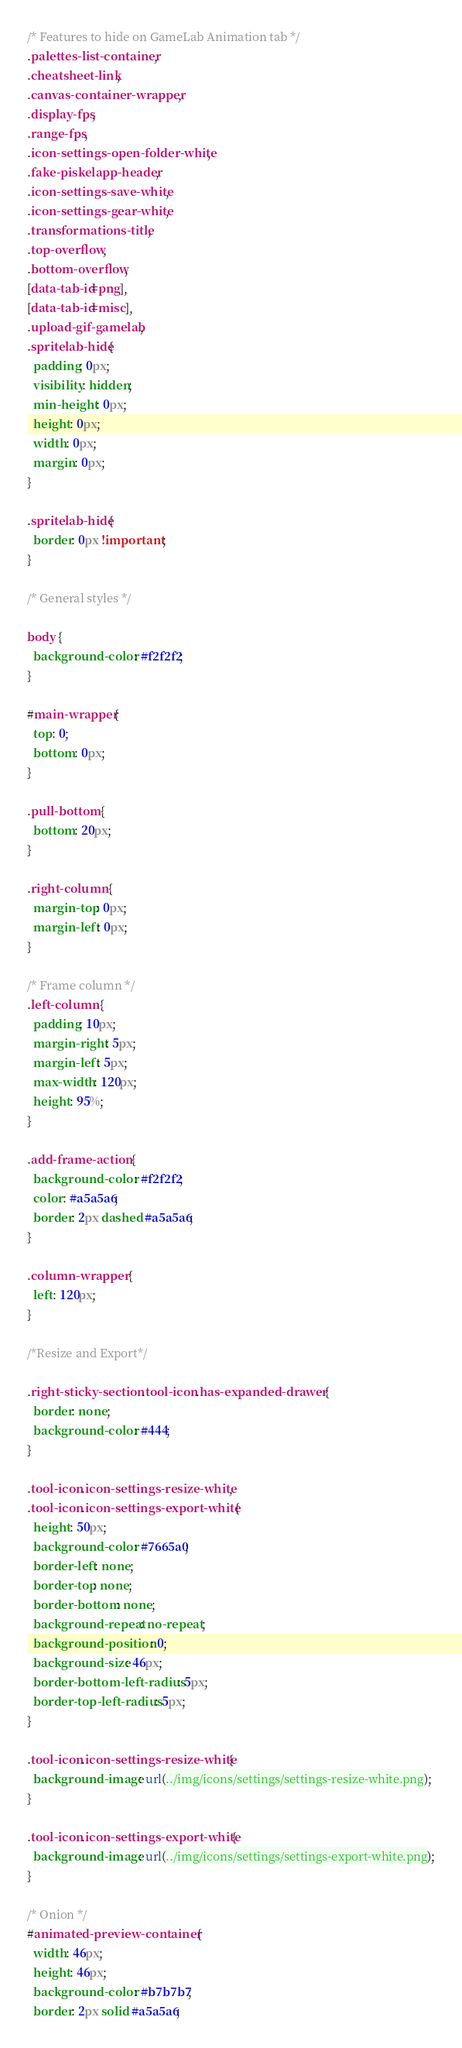Convert code to text. <code><loc_0><loc_0><loc_500><loc_500><_CSS_>/* Features to hide on GameLab Animation tab */
.palettes-list-container,
.cheatsheet-link,
.canvas-container-wrapper,
.display-fps,
.range-fps,
.icon-settings-open-folder-white,
.fake-piskelapp-header,
.icon-settings-save-white,
.icon-settings-gear-white,
.transformations-title,
.top-overflow,
.bottom-overflow,
[data-tab-id=png],
[data-tab-id=misc],
.upload-gif-gamelab,
.spritelab-hide{
  padding: 0px;
  visibility: hidden;
  min-height: 0px;
  height: 0px;
  width: 0px;
  margin: 0px;
}

.spritelab-hide{
  border: 0px !important;
}

/* General styles */

body {
  background-color: #f2f2f2;
}

#main-wrapper{
  top: 0;
  bottom: 0px;
}

.pull-bottom {
  bottom: 20px;
}

.right-column {
  margin-top: 0px;
  margin-left: 0px;
}

/* Frame column */
.left-column {
  padding: 10px;
  margin-right: 5px;
  margin-left: 5px;
  max-width: 120px;
  height: 95%;
}

.add-frame-action {
  background-color: #f2f2f2;
  color: #a5a5a6;
  border: 2px dashed #a5a5a6;
}

.column-wrapper {
  left: 120px;
}

/*Resize and Export*/

.right-sticky-section .tool-icon.has-expanded-drawer {
  border: none;
  background-color: #444;
}

.tool-icon.icon-settings-resize-white,
.tool-icon.icon-settings-export-white {
  height: 50px;
  background-color: #7665a0;
  border-left: none;
  border-top: none;
  border-bottom: none;
  background-repeat: no-repeat;
  background-position: 0;
  background-size: 46px;
  border-bottom-left-radius: 5px;
  border-top-left-radius: 5px;
}

.tool-icon.icon-settings-resize-white{
  background-image: url(../img/icons/settings/settings-resize-white.png);
}

.tool-icon.icon-settings-export-white{
  background-image: url(../img/icons/settings/settings-export-white.png);
}

/* Onion */
#animated-preview-container {
  width: 46px;
  height: 46px;
  background-color: #b7b7b7;
  border: 2px solid #a5a5a6;</code> 